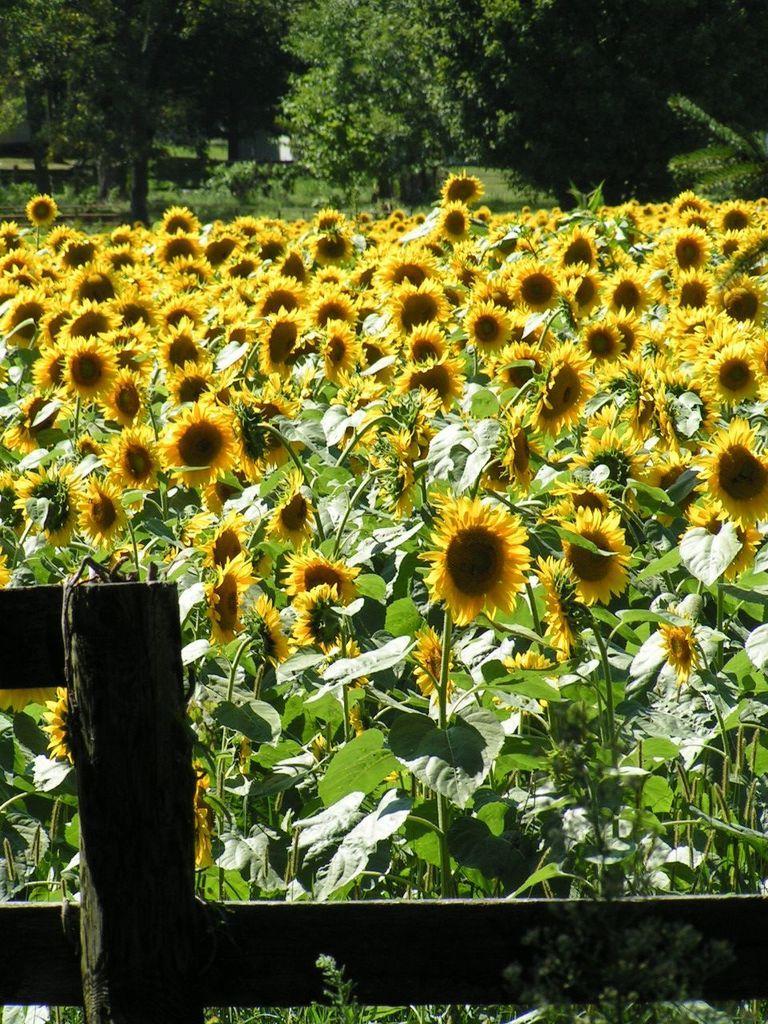Describe this image in one or two sentences. In this image in front there is a fence. Behind the fence there are plants and flowers. In the background of the image there are trees. 